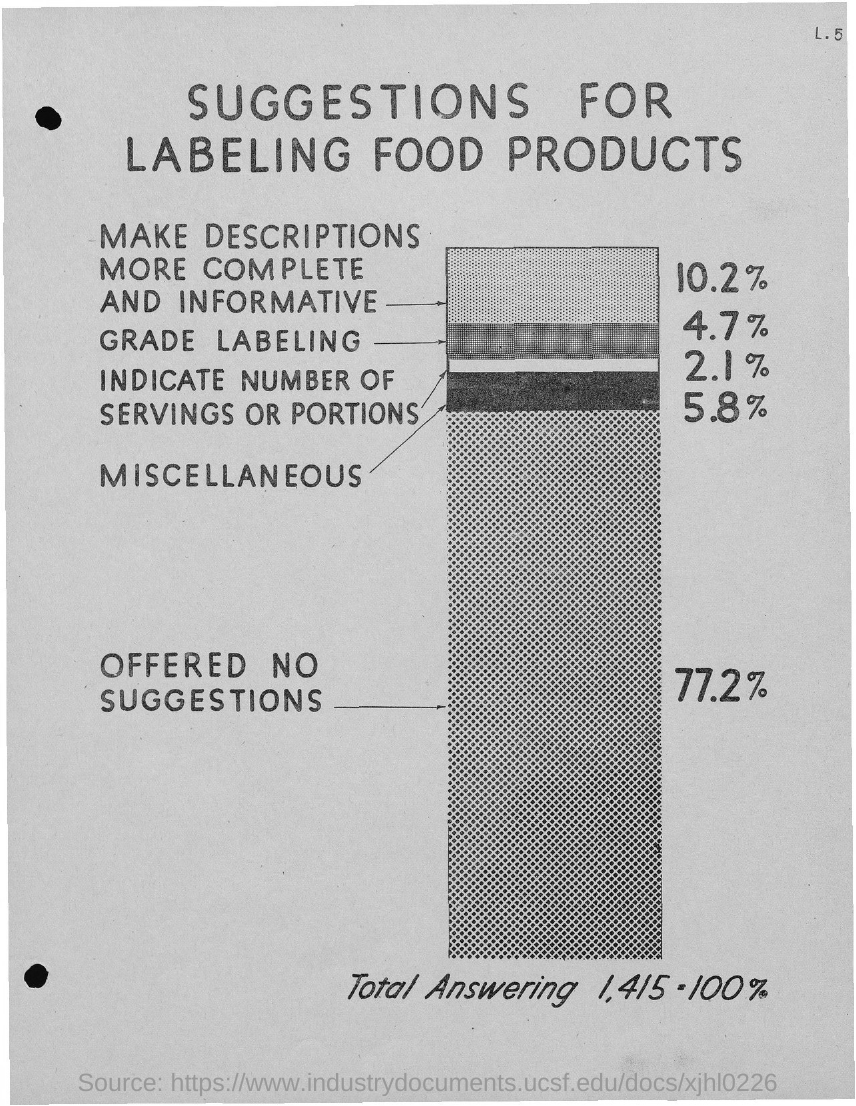Mention a couple of crucial points in this snapshot. The title of the document is 'Suggestions for Labeling Food Products'. 